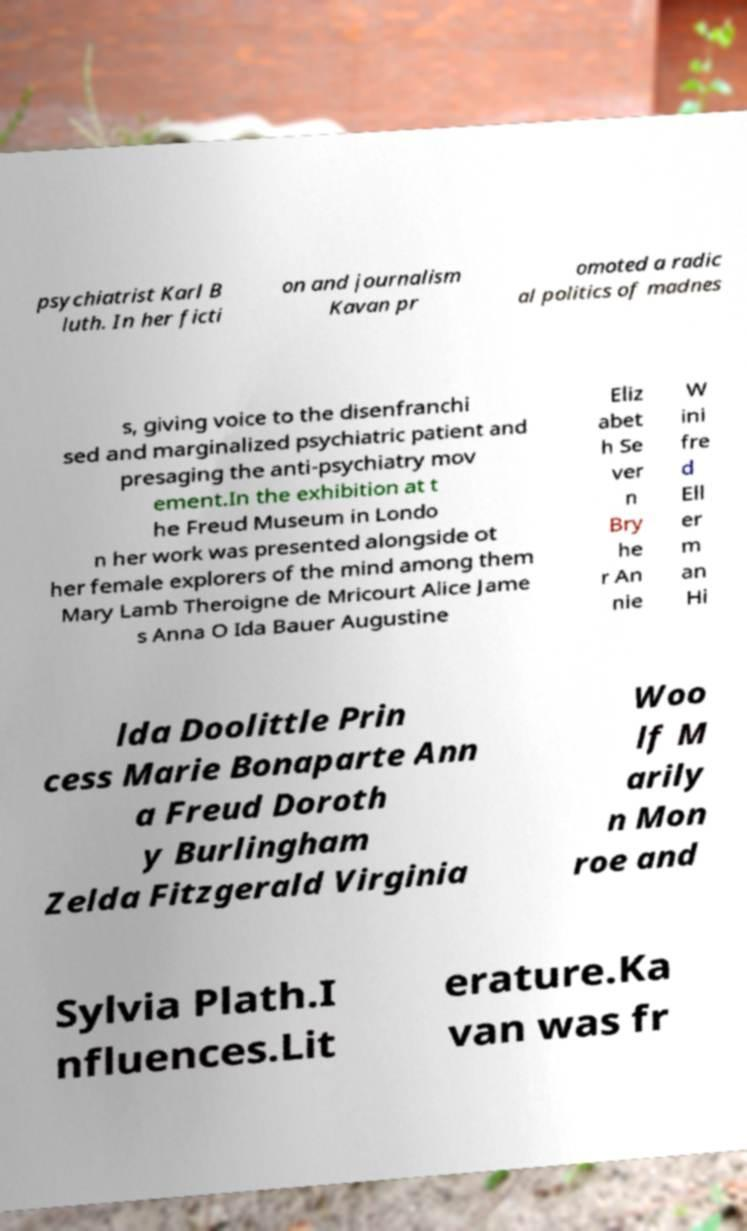Could you assist in decoding the text presented in this image and type it out clearly? psychiatrist Karl B luth. In her ficti on and journalism Kavan pr omoted a radic al politics of madnes s, giving voice to the disenfranchi sed and marginalized psychiatric patient and presaging the anti-psychiatry mov ement.In the exhibition at t he Freud Museum in Londo n her work was presented alongside ot her female explorers of the mind among them Mary Lamb Theroigne de Mricourt Alice Jame s Anna O Ida Bauer Augustine Eliz abet h Se ver n Bry he r An nie W ini fre d Ell er m an Hi lda Doolittle Prin cess Marie Bonaparte Ann a Freud Doroth y Burlingham Zelda Fitzgerald Virginia Woo lf M arily n Mon roe and Sylvia Plath.I nfluences.Lit erature.Ka van was fr 